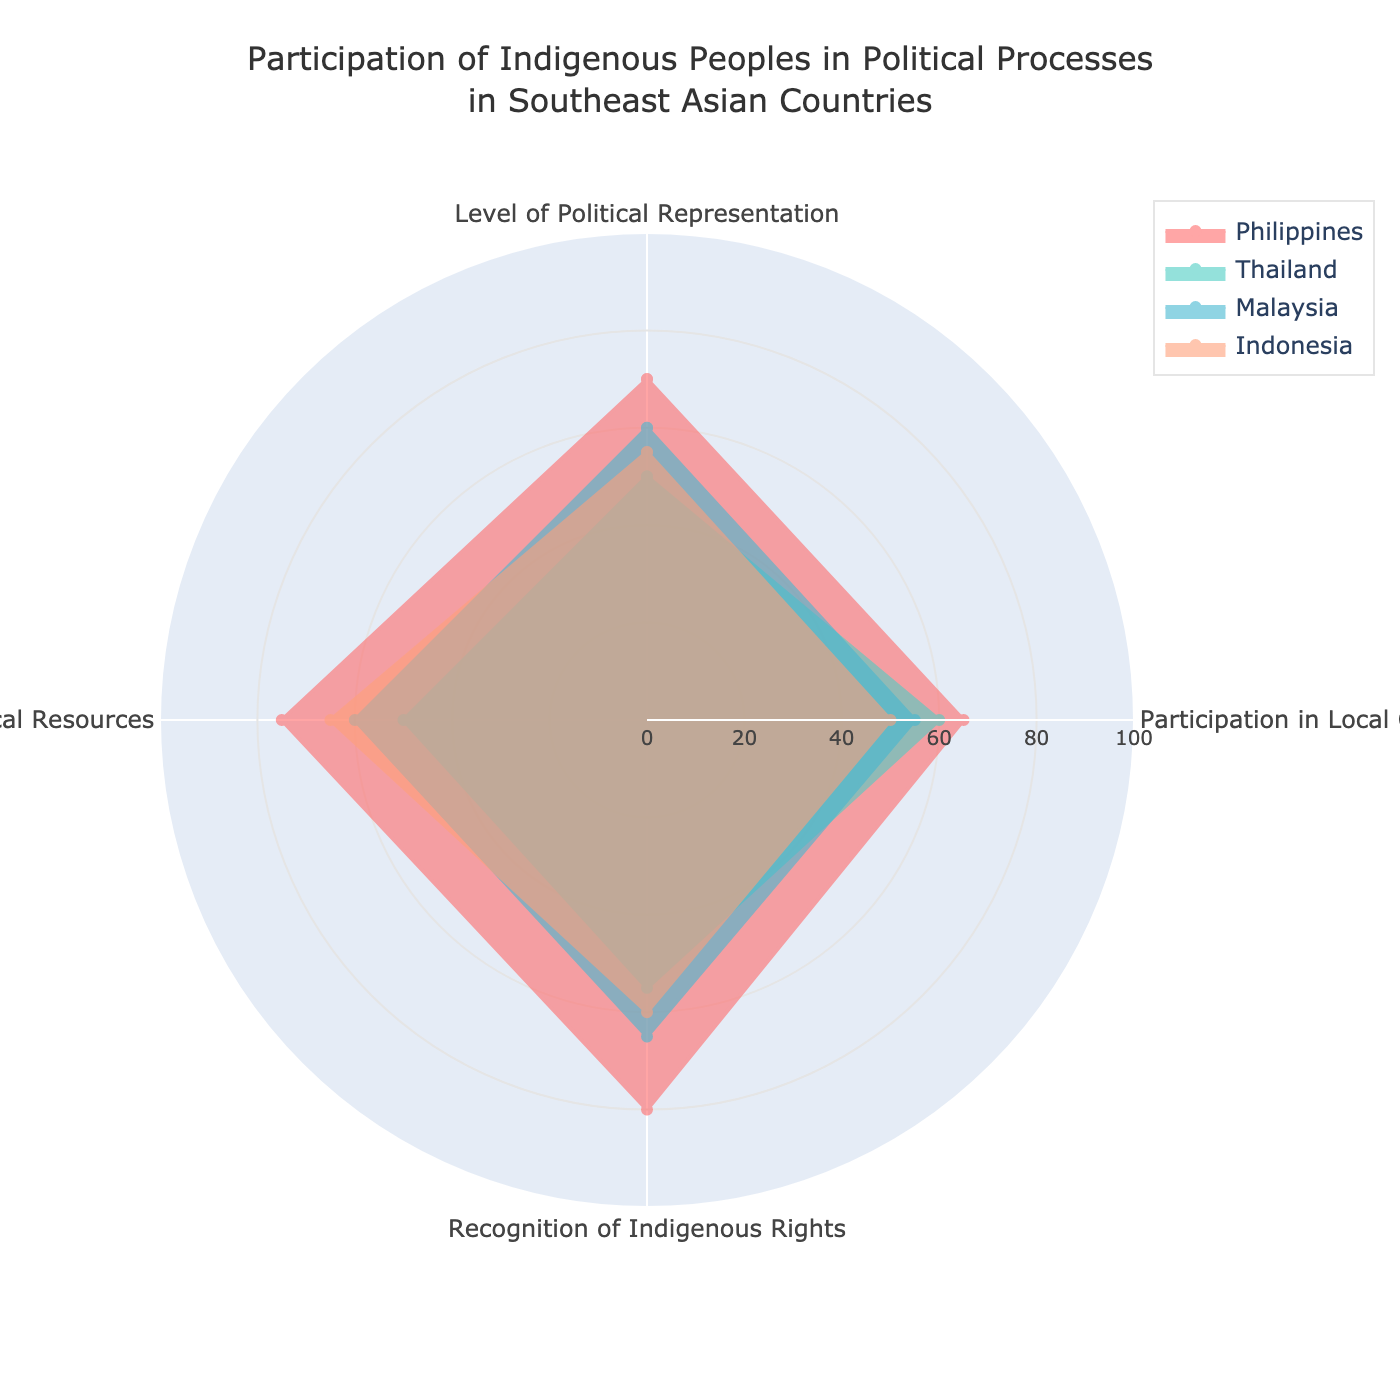How many countries are represented in the radar chart? The radar chart represents data for four countries.
Answer: Four What country shows the highest value for Recognition of Indigenous Rights? By looking at the 'Recognition of Indigenous Rights' axis, the Philippines demonstrates the highest value at 80.
Answer: Philippines Which country has the lowest participation in Local Governance? Checking the 'Participation in Local Governance' axis, Indonesia has the lowest value at 50.
Answer: Indonesia Compare the Level of Political Representation between the Philippines and Thailand. Which country has a higher value? The Philippines has a Level of Political Representation value of 70, while Thailand has 50. Hence, the Philippines has a higher value.
Answer: Philippines What country has the most balanced values across all categories? Examining the chart visually, Malaysia’s values are fairly consistent across all categories (ranging from 55 to 65) compared to others.
Answer: Malaysia What is the average Access to Political Resources value for all countries? Adding the Access to Political Resources values (Philippines: 75, Thailand: 50, Malaysia: 60, Indonesia: 65) gives (75 + 50 + 60 + 65) = 250. Dividing by the number of countries (4), the average is 250/4.
Answer: 62.5 How much higher is the Participation in Local Governance in the Philippines compared to Thailand? The Philippines has a Participation in Local Governance value of 65, and Thailand has 60. Therefore, it is 65 - 60 = 5 units higher.
Answer: 5 